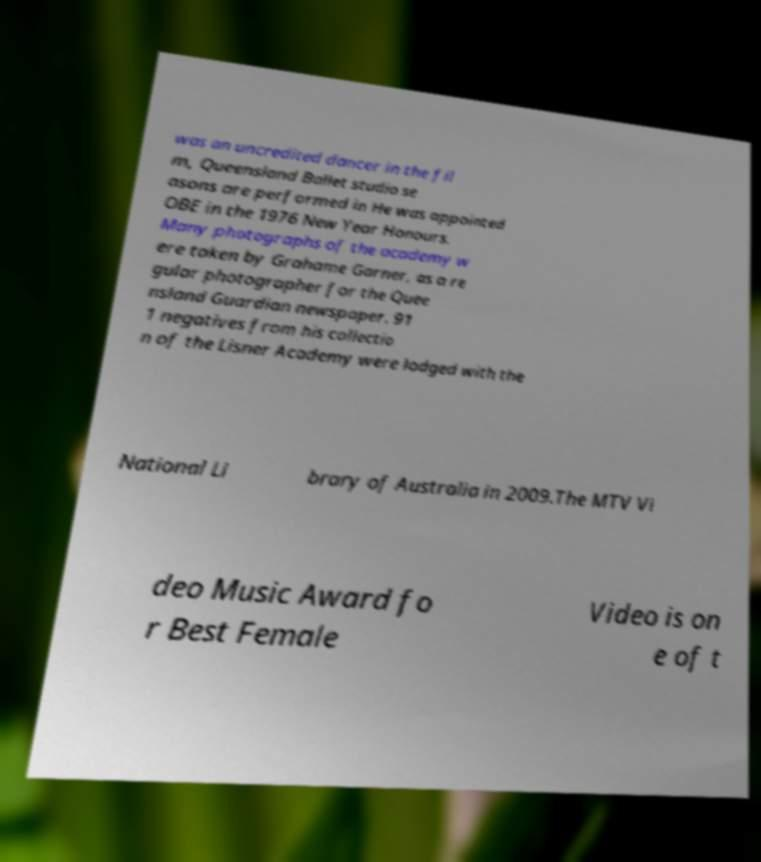Please read and relay the text visible in this image. What does it say? was an uncredited dancer in the fil m, Queensland Ballet studio se asons are performed in He was appointed OBE in the 1976 New Year Honours. Many photographs of the academy w ere taken by Grahame Garner, as a re gular photographer for the Quee nsland Guardian newspaper. 91 1 negatives from his collectio n of the Lisner Academy were lodged with the National Li brary of Australia in 2009.The MTV Vi deo Music Award fo r Best Female Video is on e of t 